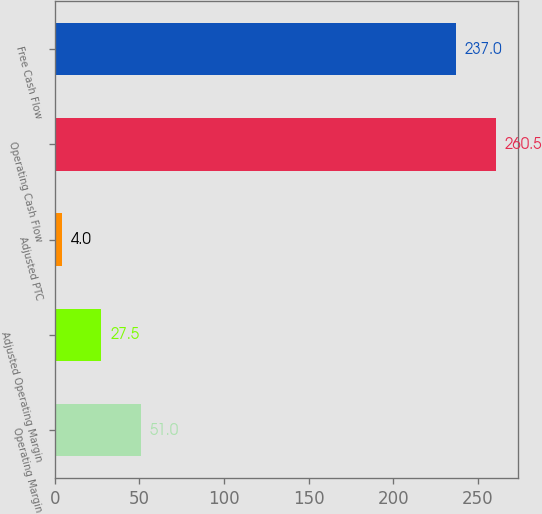Convert chart to OTSL. <chart><loc_0><loc_0><loc_500><loc_500><bar_chart><fcel>Operating Margin<fcel>Adjusted Operating Margin<fcel>Adjusted PTC<fcel>Operating Cash Flow<fcel>Free Cash Flow<nl><fcel>51<fcel>27.5<fcel>4<fcel>260.5<fcel>237<nl></chart> 